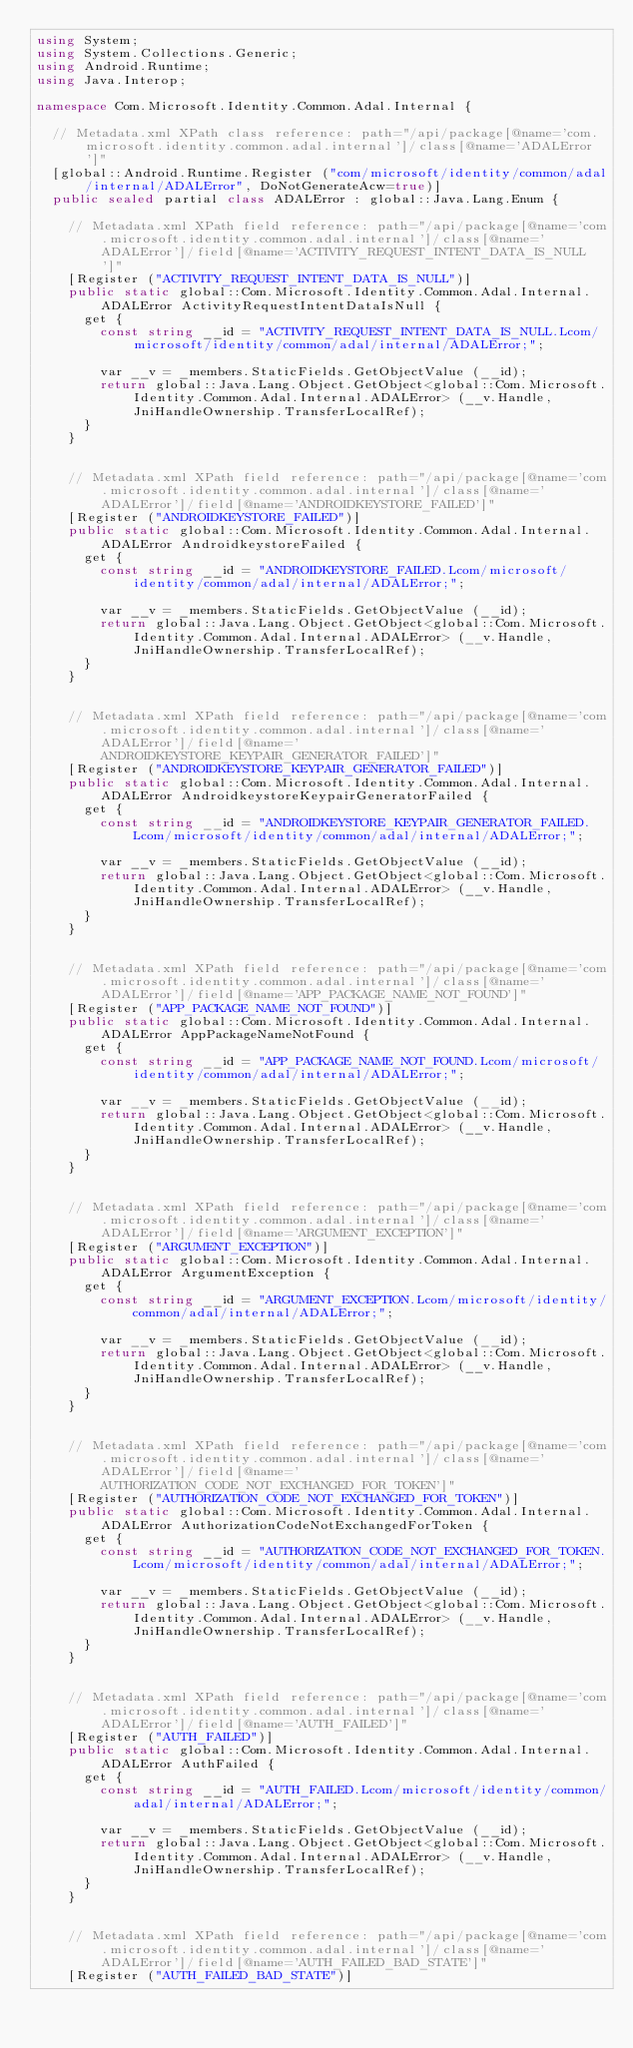<code> <loc_0><loc_0><loc_500><loc_500><_C#_>using System;
using System.Collections.Generic;
using Android.Runtime;
using Java.Interop;

namespace Com.Microsoft.Identity.Common.Adal.Internal {

	// Metadata.xml XPath class reference: path="/api/package[@name='com.microsoft.identity.common.adal.internal']/class[@name='ADALError']"
	[global::Android.Runtime.Register ("com/microsoft/identity/common/adal/internal/ADALError", DoNotGenerateAcw=true)]
	public sealed partial class ADALError : global::Java.Lang.Enum {

		// Metadata.xml XPath field reference: path="/api/package[@name='com.microsoft.identity.common.adal.internal']/class[@name='ADALError']/field[@name='ACTIVITY_REQUEST_INTENT_DATA_IS_NULL']"
		[Register ("ACTIVITY_REQUEST_INTENT_DATA_IS_NULL")]
		public static global::Com.Microsoft.Identity.Common.Adal.Internal.ADALError ActivityRequestIntentDataIsNull {
			get {
				const string __id = "ACTIVITY_REQUEST_INTENT_DATA_IS_NULL.Lcom/microsoft/identity/common/adal/internal/ADALError;";

				var __v = _members.StaticFields.GetObjectValue (__id);
				return global::Java.Lang.Object.GetObject<global::Com.Microsoft.Identity.Common.Adal.Internal.ADALError> (__v.Handle, JniHandleOwnership.TransferLocalRef);
			}
		}


		// Metadata.xml XPath field reference: path="/api/package[@name='com.microsoft.identity.common.adal.internal']/class[@name='ADALError']/field[@name='ANDROIDKEYSTORE_FAILED']"
		[Register ("ANDROIDKEYSTORE_FAILED")]
		public static global::Com.Microsoft.Identity.Common.Adal.Internal.ADALError AndroidkeystoreFailed {
			get {
				const string __id = "ANDROIDKEYSTORE_FAILED.Lcom/microsoft/identity/common/adal/internal/ADALError;";

				var __v = _members.StaticFields.GetObjectValue (__id);
				return global::Java.Lang.Object.GetObject<global::Com.Microsoft.Identity.Common.Adal.Internal.ADALError> (__v.Handle, JniHandleOwnership.TransferLocalRef);
			}
		}


		// Metadata.xml XPath field reference: path="/api/package[@name='com.microsoft.identity.common.adal.internal']/class[@name='ADALError']/field[@name='ANDROIDKEYSTORE_KEYPAIR_GENERATOR_FAILED']"
		[Register ("ANDROIDKEYSTORE_KEYPAIR_GENERATOR_FAILED")]
		public static global::Com.Microsoft.Identity.Common.Adal.Internal.ADALError AndroidkeystoreKeypairGeneratorFailed {
			get {
				const string __id = "ANDROIDKEYSTORE_KEYPAIR_GENERATOR_FAILED.Lcom/microsoft/identity/common/adal/internal/ADALError;";

				var __v = _members.StaticFields.GetObjectValue (__id);
				return global::Java.Lang.Object.GetObject<global::Com.Microsoft.Identity.Common.Adal.Internal.ADALError> (__v.Handle, JniHandleOwnership.TransferLocalRef);
			}
		}


		// Metadata.xml XPath field reference: path="/api/package[@name='com.microsoft.identity.common.adal.internal']/class[@name='ADALError']/field[@name='APP_PACKAGE_NAME_NOT_FOUND']"
		[Register ("APP_PACKAGE_NAME_NOT_FOUND")]
		public static global::Com.Microsoft.Identity.Common.Adal.Internal.ADALError AppPackageNameNotFound {
			get {
				const string __id = "APP_PACKAGE_NAME_NOT_FOUND.Lcom/microsoft/identity/common/adal/internal/ADALError;";

				var __v = _members.StaticFields.GetObjectValue (__id);
				return global::Java.Lang.Object.GetObject<global::Com.Microsoft.Identity.Common.Adal.Internal.ADALError> (__v.Handle, JniHandleOwnership.TransferLocalRef);
			}
		}


		// Metadata.xml XPath field reference: path="/api/package[@name='com.microsoft.identity.common.adal.internal']/class[@name='ADALError']/field[@name='ARGUMENT_EXCEPTION']"
		[Register ("ARGUMENT_EXCEPTION")]
		public static global::Com.Microsoft.Identity.Common.Adal.Internal.ADALError ArgumentException {
			get {
				const string __id = "ARGUMENT_EXCEPTION.Lcom/microsoft/identity/common/adal/internal/ADALError;";

				var __v = _members.StaticFields.GetObjectValue (__id);
				return global::Java.Lang.Object.GetObject<global::Com.Microsoft.Identity.Common.Adal.Internal.ADALError> (__v.Handle, JniHandleOwnership.TransferLocalRef);
			}
		}


		// Metadata.xml XPath field reference: path="/api/package[@name='com.microsoft.identity.common.adal.internal']/class[@name='ADALError']/field[@name='AUTHORIZATION_CODE_NOT_EXCHANGED_FOR_TOKEN']"
		[Register ("AUTHORIZATION_CODE_NOT_EXCHANGED_FOR_TOKEN")]
		public static global::Com.Microsoft.Identity.Common.Adal.Internal.ADALError AuthorizationCodeNotExchangedForToken {
			get {
				const string __id = "AUTHORIZATION_CODE_NOT_EXCHANGED_FOR_TOKEN.Lcom/microsoft/identity/common/adal/internal/ADALError;";

				var __v = _members.StaticFields.GetObjectValue (__id);
				return global::Java.Lang.Object.GetObject<global::Com.Microsoft.Identity.Common.Adal.Internal.ADALError> (__v.Handle, JniHandleOwnership.TransferLocalRef);
			}
		}


		// Metadata.xml XPath field reference: path="/api/package[@name='com.microsoft.identity.common.adal.internal']/class[@name='ADALError']/field[@name='AUTH_FAILED']"
		[Register ("AUTH_FAILED")]
		public static global::Com.Microsoft.Identity.Common.Adal.Internal.ADALError AuthFailed {
			get {
				const string __id = "AUTH_FAILED.Lcom/microsoft/identity/common/adal/internal/ADALError;";

				var __v = _members.StaticFields.GetObjectValue (__id);
				return global::Java.Lang.Object.GetObject<global::Com.Microsoft.Identity.Common.Adal.Internal.ADALError> (__v.Handle, JniHandleOwnership.TransferLocalRef);
			}
		}


		// Metadata.xml XPath field reference: path="/api/package[@name='com.microsoft.identity.common.adal.internal']/class[@name='ADALError']/field[@name='AUTH_FAILED_BAD_STATE']"
		[Register ("AUTH_FAILED_BAD_STATE")]</code> 